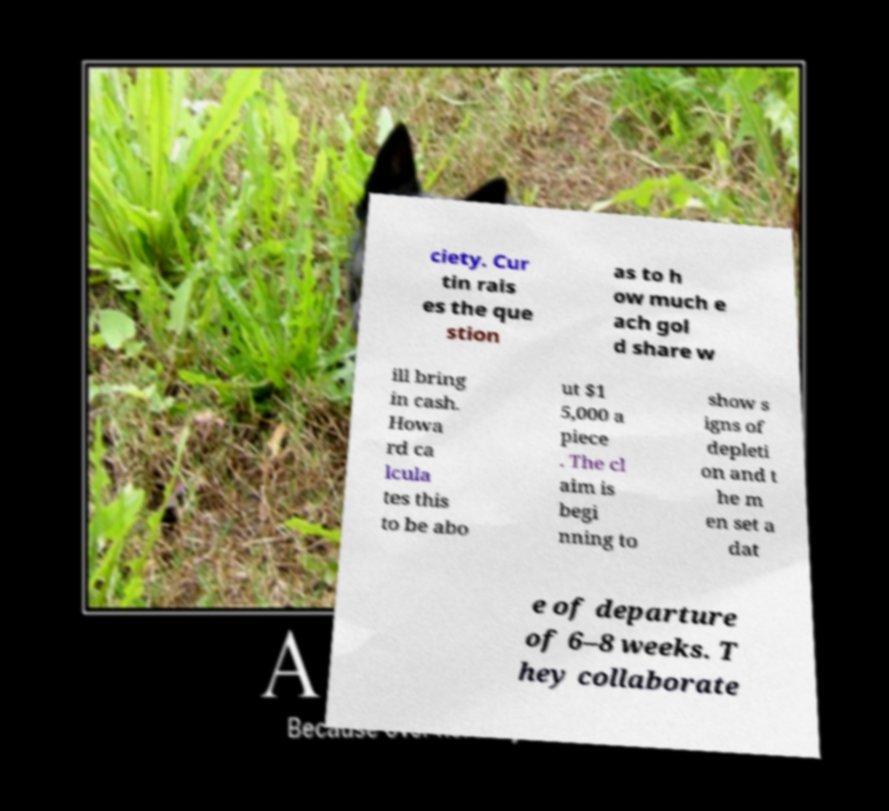Please read and relay the text visible in this image. What does it say? ciety. Cur tin rais es the que stion as to h ow much e ach gol d share w ill bring in cash. Howa rd ca lcula tes this to be abo ut $1 5,000 a piece . The cl aim is begi nning to show s igns of depleti on and t he m en set a dat e of departure of 6–8 weeks. T hey collaborate 